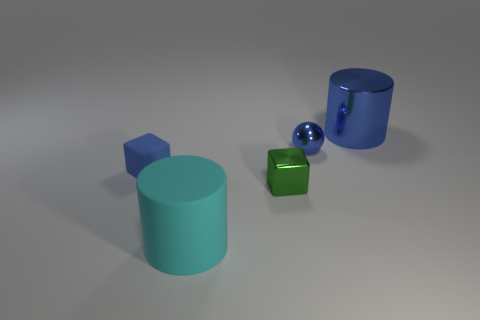There is a blue rubber thing that is the same size as the green metal object; what shape is it?
Offer a very short reply. Cube. What material is the other cylinder that is the same size as the cyan rubber cylinder?
Provide a succinct answer. Metal. Do the tiny blue object that is on the right side of the blue matte cube and the large blue metallic thing have the same shape?
Provide a short and direct response. No. There is another green object that is the same shape as the small matte object; what is it made of?
Offer a terse response. Metal. Are there any small blue rubber blocks?
Your answer should be compact. Yes. What material is the large object on the right side of the metallic object that is to the left of the tiny blue object that is on the right side of the small matte object?
Keep it short and to the point. Metal. Does the small rubber thing have the same shape as the shiny thing that is in front of the tiny blue matte object?
Ensure brevity in your answer.  Yes. What number of small blue metallic objects have the same shape as the large shiny thing?
Your answer should be very brief. 0. The small blue shiny thing has what shape?
Ensure brevity in your answer.  Sphere. What is the size of the cube that is right of the rubber object that is behind the small green object?
Your answer should be compact. Small. 